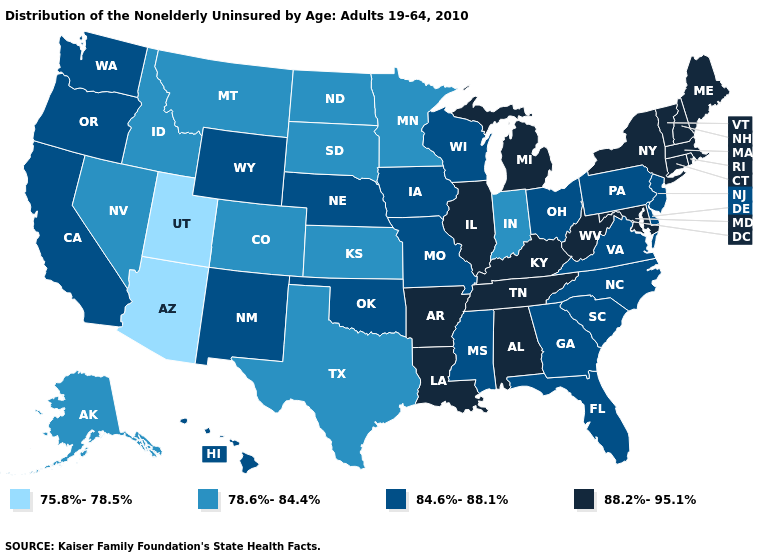Name the states that have a value in the range 75.8%-78.5%?
Concise answer only. Arizona, Utah. What is the value of Oklahoma?
Answer briefly. 84.6%-88.1%. What is the highest value in the MidWest ?
Short answer required. 88.2%-95.1%. What is the highest value in the South ?
Concise answer only. 88.2%-95.1%. What is the value of Oregon?
Write a very short answer. 84.6%-88.1%. What is the value of Vermont?
Write a very short answer. 88.2%-95.1%. Does Wisconsin have the same value as Maine?
Write a very short answer. No. What is the highest value in states that border New Jersey?
Keep it brief. 88.2%-95.1%. Among the states that border Idaho , which have the highest value?
Concise answer only. Oregon, Washington, Wyoming. Does Tennessee have the same value as Ohio?
Concise answer only. No. Name the states that have a value in the range 88.2%-95.1%?
Give a very brief answer. Alabama, Arkansas, Connecticut, Illinois, Kentucky, Louisiana, Maine, Maryland, Massachusetts, Michigan, New Hampshire, New York, Rhode Island, Tennessee, Vermont, West Virginia. Does Iowa have a higher value than Illinois?
Keep it brief. No. Which states hav the highest value in the MidWest?
Write a very short answer. Illinois, Michigan. Name the states that have a value in the range 75.8%-78.5%?
Short answer required. Arizona, Utah. What is the highest value in the USA?
Short answer required. 88.2%-95.1%. 